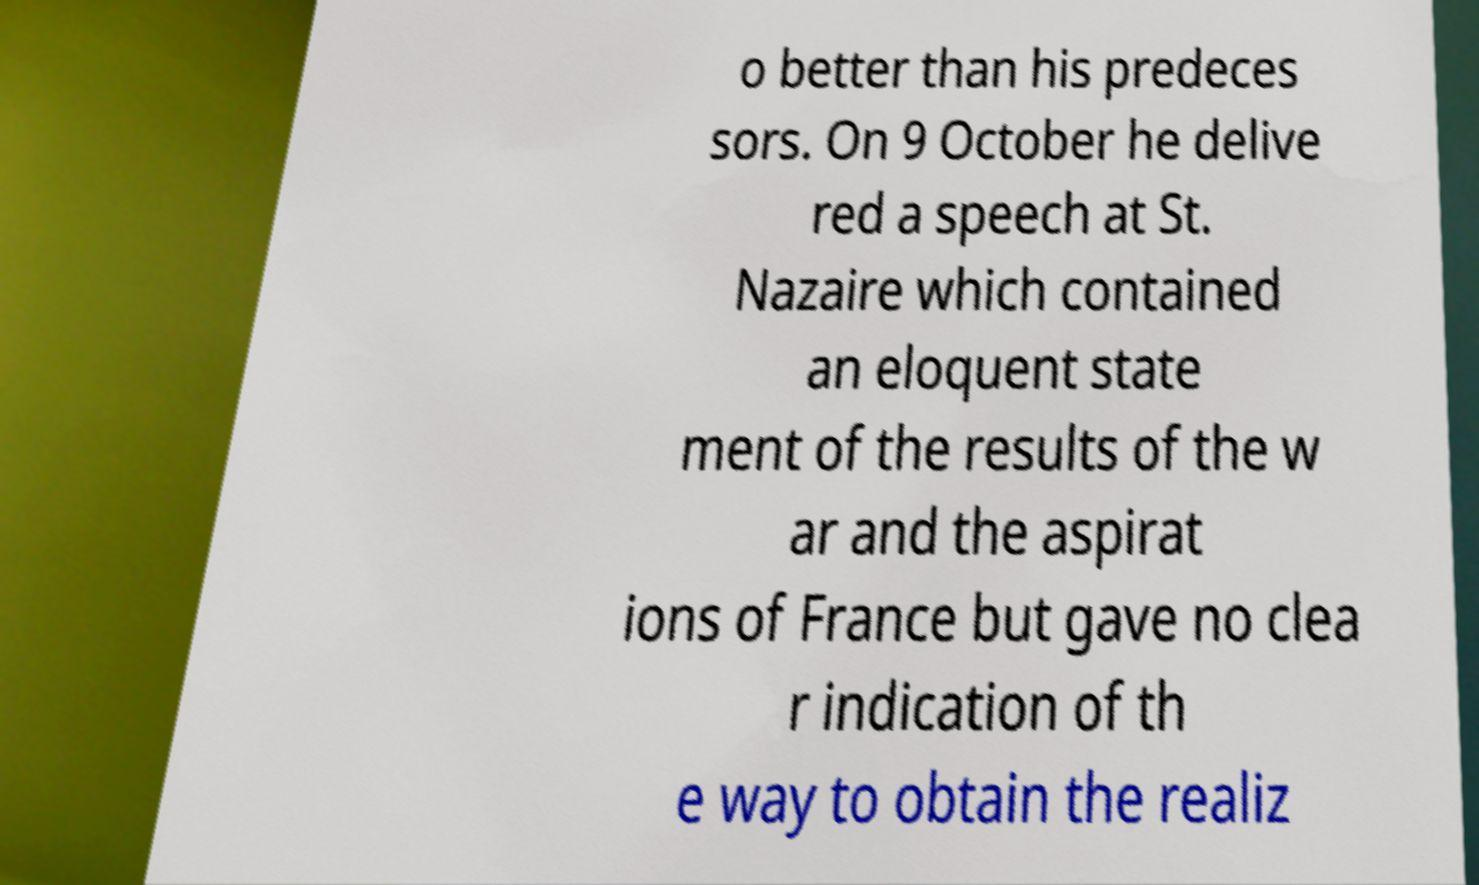There's text embedded in this image that I need extracted. Can you transcribe it verbatim? o better than his predeces sors. On 9 October he delive red a speech at St. Nazaire which contained an eloquent state ment of the results of the w ar and the aspirat ions of France but gave no clea r indication of th e way to obtain the realiz 